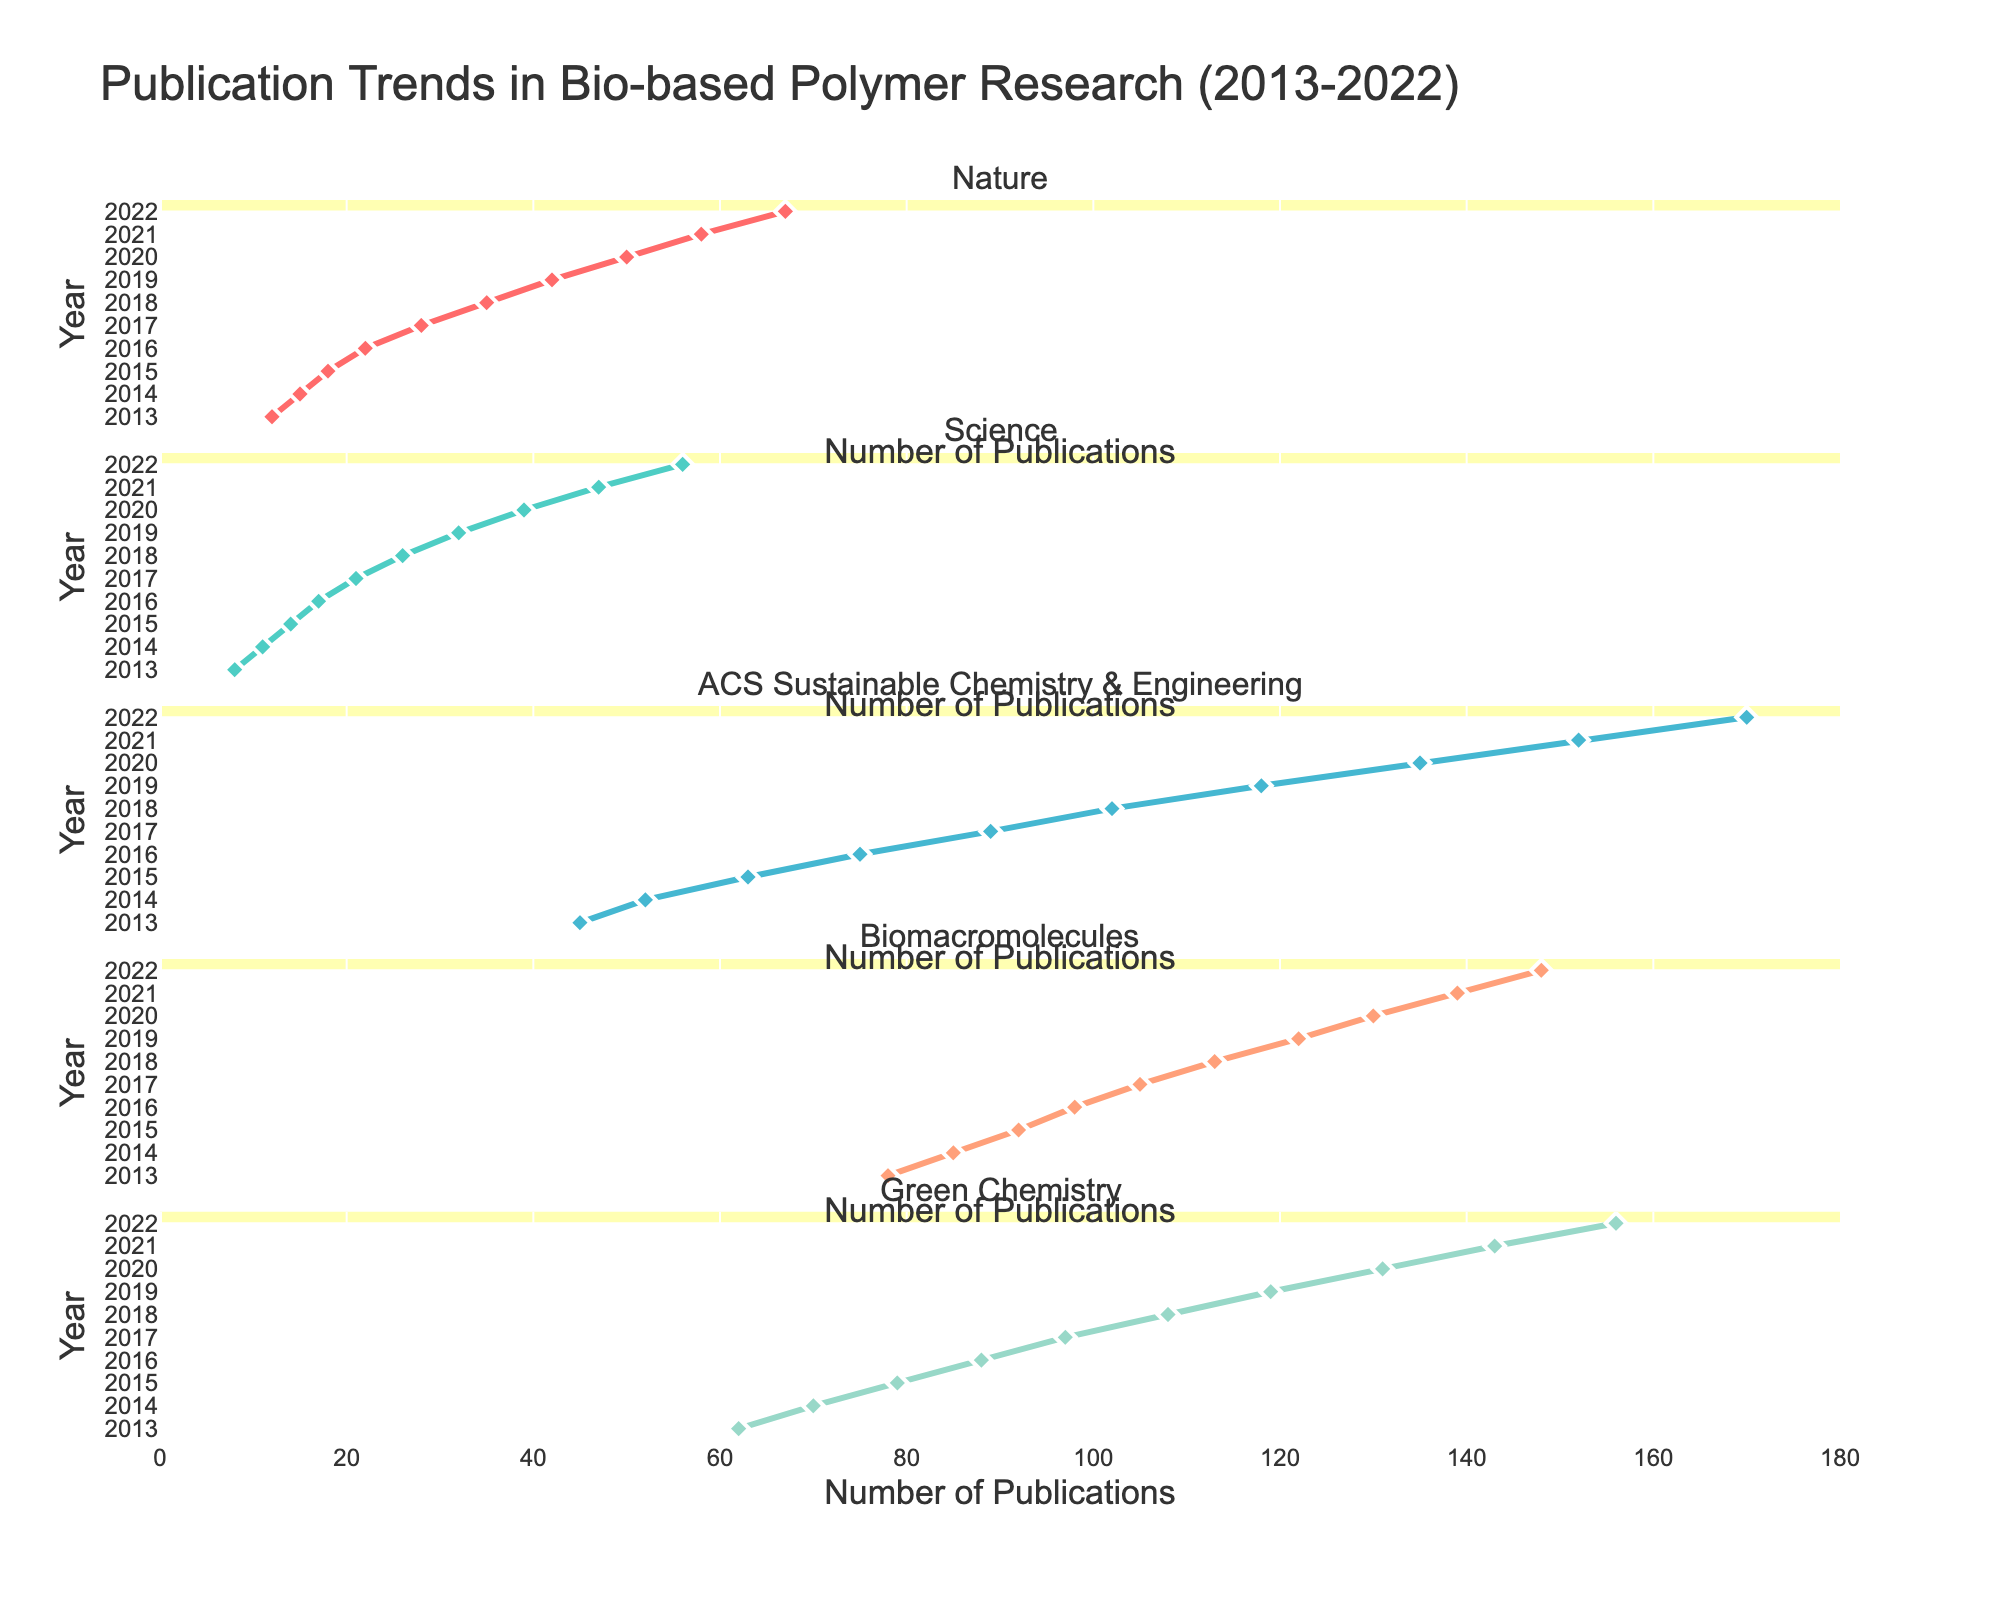What's the total height a puppy gains from 0 to 12 months? To find the total height gain, subtract the height at 0 months from the height at 12 months (22 inches - 3 inches).
Answer: 19 inches Which pet shows the fastest weight growth in the first 6 months? To determine the fastest weight growth, compare the weight increase for each pet over the first 6 months. Puppies increase from 1 to 30 lbs, kittens from 0.2 to 6 lbs, rabbits from 0.1 to 3 lbs, and hamsters from 0.5 to 3.5 oz. Puppies show the largest increase.
Answer: Puppy At 9 months, which pet has grown the most in length or height? Compare the growth at 9 months for all pets. Puppy height is 20 inches, kitten height is 12 inches, rabbit length is 12 inches, and hamster length is 5.5 inches. The puppy has grown the most.
Answer: Puppy What's the average weight of a rabbit at all measured months? Add the rabbit weights at each month and divide by the total number of months (0.1+0.5+1+1.5+2+2.5+3+4+5) and divide by 9. The sum is 20.1, so the average is 20.1 / 9.
Answer: 2.23 lbs Which pet's height is the most stable over time? By examining the changes in height or length over time. Rabbits remain relatively steady with a gradual increase, while others show sharper changes.
Answer: Rabbit Does the weight of hamsters ever surpass 4 oz in the given data? Check the weights over the months for hamsters; they increase to 4.5 oz at 12 months.
Answer: Yes 